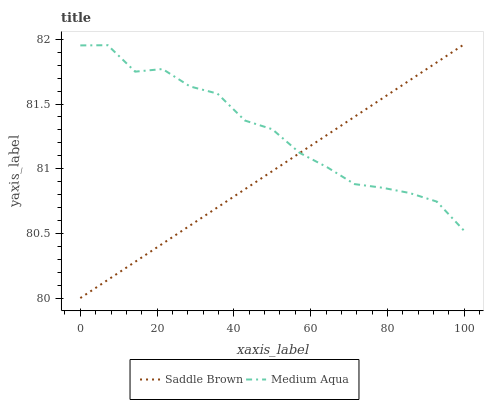Does Saddle Brown have the minimum area under the curve?
Answer yes or no. Yes. Does Medium Aqua have the maximum area under the curve?
Answer yes or no. Yes. Does Saddle Brown have the maximum area under the curve?
Answer yes or no. No. Is Saddle Brown the smoothest?
Answer yes or no. Yes. Is Medium Aqua the roughest?
Answer yes or no. Yes. Is Saddle Brown the roughest?
Answer yes or no. No. Does Saddle Brown have the lowest value?
Answer yes or no. Yes. Does Saddle Brown have the highest value?
Answer yes or no. Yes. Does Medium Aqua intersect Saddle Brown?
Answer yes or no. Yes. Is Medium Aqua less than Saddle Brown?
Answer yes or no. No. Is Medium Aqua greater than Saddle Brown?
Answer yes or no. No. 